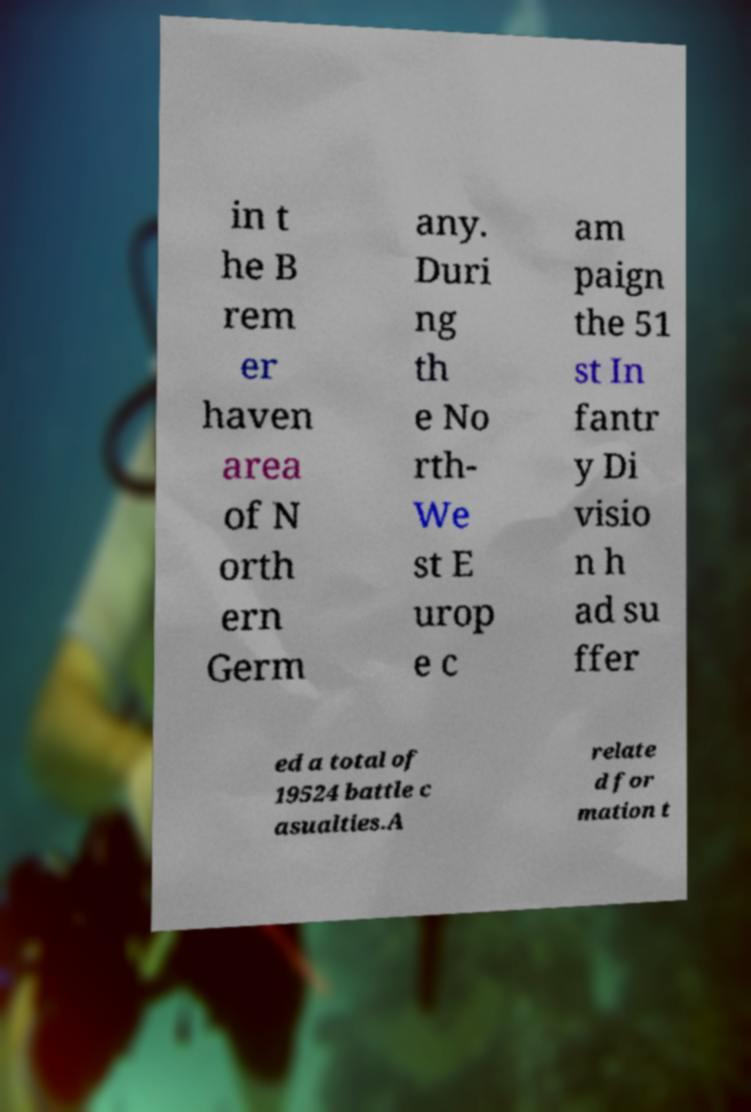Can you accurately transcribe the text from the provided image for me? in t he B rem er haven area of N orth ern Germ any. Duri ng th e No rth- We st E urop e c am paign the 51 st In fantr y Di visio n h ad su ffer ed a total of 19524 battle c asualties.A relate d for mation t 